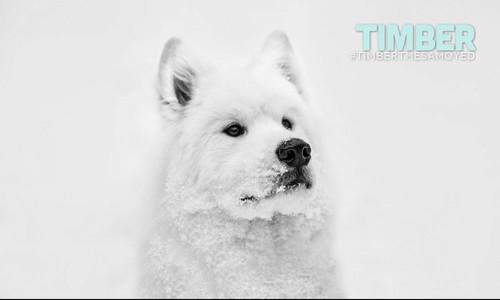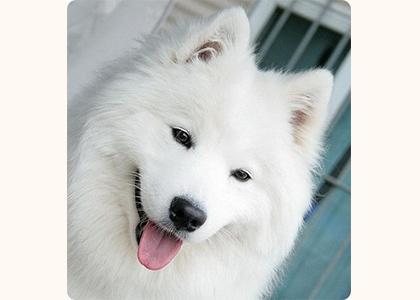The first image is the image on the left, the second image is the image on the right. Considering the images on both sides, is "There is a lone dog with it's mouth open and tongue hanging out." valid? Answer yes or no. Yes. 